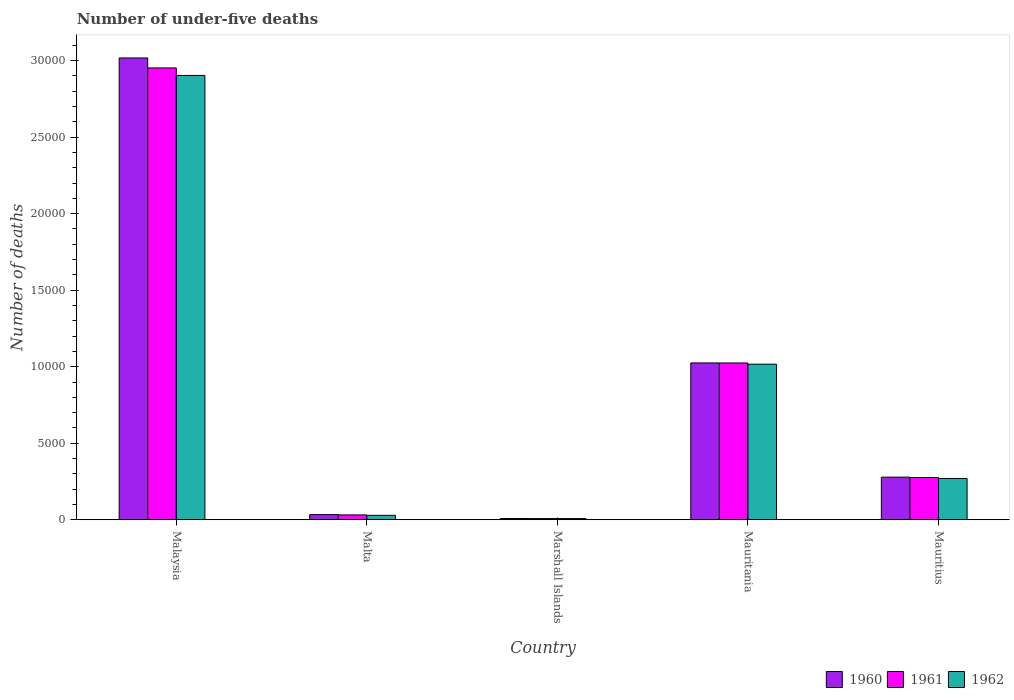How many different coloured bars are there?
Offer a very short reply. 3. Are the number of bars per tick equal to the number of legend labels?
Keep it short and to the point. Yes. Are the number of bars on each tick of the X-axis equal?
Provide a succinct answer. Yes. How many bars are there on the 5th tick from the left?
Your answer should be compact. 3. How many bars are there on the 4th tick from the right?
Make the answer very short. 3. What is the label of the 5th group of bars from the left?
Give a very brief answer. Mauritius. In how many cases, is the number of bars for a given country not equal to the number of legend labels?
Your response must be concise. 0. What is the number of under-five deaths in 1961 in Marshall Islands?
Make the answer very short. 79. Across all countries, what is the maximum number of under-five deaths in 1960?
Give a very brief answer. 3.02e+04. Across all countries, what is the minimum number of under-five deaths in 1962?
Give a very brief answer. 78. In which country was the number of under-five deaths in 1961 maximum?
Offer a very short reply. Malaysia. In which country was the number of under-five deaths in 1961 minimum?
Give a very brief answer. Marshall Islands. What is the total number of under-five deaths in 1962 in the graph?
Ensure brevity in your answer.  4.23e+04. What is the difference between the number of under-five deaths in 1962 in Malta and that in Mauritania?
Ensure brevity in your answer.  -9876. What is the difference between the number of under-five deaths in 1961 in Mauritius and the number of under-five deaths in 1962 in Mauritania?
Make the answer very short. -7404. What is the average number of under-five deaths in 1961 per country?
Offer a terse response. 8585.4. In how many countries, is the number of under-five deaths in 1961 greater than 20000?
Keep it short and to the point. 1. What is the ratio of the number of under-five deaths in 1960 in Mauritania to that in Mauritius?
Your response must be concise. 3.68. What is the difference between the highest and the second highest number of under-five deaths in 1960?
Offer a very short reply. 7463. What is the difference between the highest and the lowest number of under-five deaths in 1962?
Provide a short and direct response. 2.90e+04. Is the sum of the number of under-five deaths in 1960 in Marshall Islands and Mauritius greater than the maximum number of under-five deaths in 1961 across all countries?
Your response must be concise. No. What does the 1st bar from the left in Mauritania represents?
Your answer should be very brief. 1960. How many bars are there?
Make the answer very short. 15. How many countries are there in the graph?
Provide a succinct answer. 5. What is the difference between two consecutive major ticks on the Y-axis?
Give a very brief answer. 5000. Are the values on the major ticks of Y-axis written in scientific E-notation?
Give a very brief answer. No. Where does the legend appear in the graph?
Give a very brief answer. Bottom right. What is the title of the graph?
Provide a succinct answer. Number of under-five deaths. Does "1966" appear as one of the legend labels in the graph?
Offer a very short reply. No. What is the label or title of the Y-axis?
Provide a succinct answer. Number of deaths. What is the Number of deaths of 1960 in Malaysia?
Your response must be concise. 3.02e+04. What is the Number of deaths in 1961 in Malaysia?
Offer a very short reply. 2.95e+04. What is the Number of deaths in 1962 in Malaysia?
Ensure brevity in your answer.  2.90e+04. What is the Number of deaths in 1960 in Malta?
Give a very brief answer. 336. What is the Number of deaths of 1961 in Malta?
Your answer should be compact. 317. What is the Number of deaths of 1962 in Malta?
Your answer should be compact. 290. What is the Number of deaths of 1960 in Marshall Islands?
Provide a short and direct response. 81. What is the Number of deaths of 1961 in Marshall Islands?
Your answer should be compact. 79. What is the Number of deaths of 1962 in Marshall Islands?
Your response must be concise. 78. What is the Number of deaths in 1960 in Mauritania?
Provide a succinct answer. 1.02e+04. What is the Number of deaths of 1961 in Mauritania?
Your answer should be compact. 1.02e+04. What is the Number of deaths in 1962 in Mauritania?
Offer a terse response. 1.02e+04. What is the Number of deaths of 1960 in Mauritius?
Your answer should be compact. 2785. What is the Number of deaths of 1961 in Mauritius?
Your answer should be compact. 2762. What is the Number of deaths of 1962 in Mauritius?
Make the answer very short. 2697. Across all countries, what is the maximum Number of deaths of 1960?
Give a very brief answer. 3.02e+04. Across all countries, what is the maximum Number of deaths in 1961?
Give a very brief answer. 2.95e+04. Across all countries, what is the maximum Number of deaths of 1962?
Your answer should be compact. 2.90e+04. Across all countries, what is the minimum Number of deaths of 1960?
Offer a very short reply. 81. Across all countries, what is the minimum Number of deaths in 1961?
Your answer should be compact. 79. Across all countries, what is the minimum Number of deaths in 1962?
Your response must be concise. 78. What is the total Number of deaths in 1960 in the graph?
Offer a very short reply. 4.36e+04. What is the total Number of deaths in 1961 in the graph?
Ensure brevity in your answer.  4.29e+04. What is the total Number of deaths in 1962 in the graph?
Ensure brevity in your answer.  4.23e+04. What is the difference between the Number of deaths of 1960 in Malaysia and that in Malta?
Offer a terse response. 2.98e+04. What is the difference between the Number of deaths in 1961 in Malaysia and that in Malta?
Give a very brief answer. 2.92e+04. What is the difference between the Number of deaths in 1962 in Malaysia and that in Malta?
Give a very brief answer. 2.87e+04. What is the difference between the Number of deaths of 1960 in Malaysia and that in Marshall Islands?
Give a very brief answer. 3.01e+04. What is the difference between the Number of deaths of 1961 in Malaysia and that in Marshall Islands?
Give a very brief answer. 2.94e+04. What is the difference between the Number of deaths of 1962 in Malaysia and that in Marshall Islands?
Your response must be concise. 2.90e+04. What is the difference between the Number of deaths in 1960 in Malaysia and that in Mauritania?
Provide a succinct answer. 1.99e+04. What is the difference between the Number of deaths in 1961 in Malaysia and that in Mauritania?
Ensure brevity in your answer.  1.93e+04. What is the difference between the Number of deaths in 1962 in Malaysia and that in Mauritania?
Ensure brevity in your answer.  1.89e+04. What is the difference between the Number of deaths of 1960 in Malaysia and that in Mauritius?
Make the answer very short. 2.74e+04. What is the difference between the Number of deaths in 1961 in Malaysia and that in Mauritius?
Offer a very short reply. 2.68e+04. What is the difference between the Number of deaths in 1962 in Malaysia and that in Mauritius?
Offer a terse response. 2.63e+04. What is the difference between the Number of deaths of 1960 in Malta and that in Marshall Islands?
Give a very brief answer. 255. What is the difference between the Number of deaths in 1961 in Malta and that in Marshall Islands?
Ensure brevity in your answer.  238. What is the difference between the Number of deaths of 1962 in Malta and that in Marshall Islands?
Offer a terse response. 212. What is the difference between the Number of deaths in 1960 in Malta and that in Mauritania?
Offer a very short reply. -9912. What is the difference between the Number of deaths of 1961 in Malta and that in Mauritania?
Provide a short and direct response. -9928. What is the difference between the Number of deaths in 1962 in Malta and that in Mauritania?
Your answer should be very brief. -9876. What is the difference between the Number of deaths of 1960 in Malta and that in Mauritius?
Your answer should be very brief. -2449. What is the difference between the Number of deaths of 1961 in Malta and that in Mauritius?
Your answer should be very brief. -2445. What is the difference between the Number of deaths in 1962 in Malta and that in Mauritius?
Offer a terse response. -2407. What is the difference between the Number of deaths of 1960 in Marshall Islands and that in Mauritania?
Your answer should be very brief. -1.02e+04. What is the difference between the Number of deaths of 1961 in Marshall Islands and that in Mauritania?
Your answer should be compact. -1.02e+04. What is the difference between the Number of deaths of 1962 in Marshall Islands and that in Mauritania?
Make the answer very short. -1.01e+04. What is the difference between the Number of deaths of 1960 in Marshall Islands and that in Mauritius?
Your answer should be very brief. -2704. What is the difference between the Number of deaths in 1961 in Marshall Islands and that in Mauritius?
Provide a succinct answer. -2683. What is the difference between the Number of deaths in 1962 in Marshall Islands and that in Mauritius?
Give a very brief answer. -2619. What is the difference between the Number of deaths of 1960 in Mauritania and that in Mauritius?
Offer a terse response. 7463. What is the difference between the Number of deaths of 1961 in Mauritania and that in Mauritius?
Your answer should be compact. 7483. What is the difference between the Number of deaths in 1962 in Mauritania and that in Mauritius?
Offer a very short reply. 7469. What is the difference between the Number of deaths of 1960 in Malaysia and the Number of deaths of 1961 in Malta?
Give a very brief answer. 2.99e+04. What is the difference between the Number of deaths in 1960 in Malaysia and the Number of deaths in 1962 in Malta?
Keep it short and to the point. 2.99e+04. What is the difference between the Number of deaths of 1961 in Malaysia and the Number of deaths of 1962 in Malta?
Ensure brevity in your answer.  2.92e+04. What is the difference between the Number of deaths in 1960 in Malaysia and the Number of deaths in 1961 in Marshall Islands?
Offer a very short reply. 3.01e+04. What is the difference between the Number of deaths in 1960 in Malaysia and the Number of deaths in 1962 in Marshall Islands?
Your answer should be very brief. 3.01e+04. What is the difference between the Number of deaths of 1961 in Malaysia and the Number of deaths of 1962 in Marshall Islands?
Your answer should be very brief. 2.94e+04. What is the difference between the Number of deaths in 1960 in Malaysia and the Number of deaths in 1961 in Mauritania?
Provide a succinct answer. 1.99e+04. What is the difference between the Number of deaths of 1960 in Malaysia and the Number of deaths of 1962 in Mauritania?
Offer a terse response. 2.00e+04. What is the difference between the Number of deaths in 1961 in Malaysia and the Number of deaths in 1962 in Mauritania?
Offer a terse response. 1.94e+04. What is the difference between the Number of deaths in 1960 in Malaysia and the Number of deaths in 1961 in Mauritius?
Offer a terse response. 2.74e+04. What is the difference between the Number of deaths in 1960 in Malaysia and the Number of deaths in 1962 in Mauritius?
Ensure brevity in your answer.  2.75e+04. What is the difference between the Number of deaths of 1961 in Malaysia and the Number of deaths of 1962 in Mauritius?
Provide a short and direct response. 2.68e+04. What is the difference between the Number of deaths in 1960 in Malta and the Number of deaths in 1961 in Marshall Islands?
Offer a very short reply. 257. What is the difference between the Number of deaths in 1960 in Malta and the Number of deaths in 1962 in Marshall Islands?
Keep it short and to the point. 258. What is the difference between the Number of deaths in 1961 in Malta and the Number of deaths in 1962 in Marshall Islands?
Make the answer very short. 239. What is the difference between the Number of deaths of 1960 in Malta and the Number of deaths of 1961 in Mauritania?
Your response must be concise. -9909. What is the difference between the Number of deaths in 1960 in Malta and the Number of deaths in 1962 in Mauritania?
Your response must be concise. -9830. What is the difference between the Number of deaths of 1961 in Malta and the Number of deaths of 1962 in Mauritania?
Offer a terse response. -9849. What is the difference between the Number of deaths of 1960 in Malta and the Number of deaths of 1961 in Mauritius?
Provide a short and direct response. -2426. What is the difference between the Number of deaths of 1960 in Malta and the Number of deaths of 1962 in Mauritius?
Give a very brief answer. -2361. What is the difference between the Number of deaths of 1961 in Malta and the Number of deaths of 1962 in Mauritius?
Provide a short and direct response. -2380. What is the difference between the Number of deaths of 1960 in Marshall Islands and the Number of deaths of 1961 in Mauritania?
Give a very brief answer. -1.02e+04. What is the difference between the Number of deaths of 1960 in Marshall Islands and the Number of deaths of 1962 in Mauritania?
Make the answer very short. -1.01e+04. What is the difference between the Number of deaths of 1961 in Marshall Islands and the Number of deaths of 1962 in Mauritania?
Give a very brief answer. -1.01e+04. What is the difference between the Number of deaths of 1960 in Marshall Islands and the Number of deaths of 1961 in Mauritius?
Offer a terse response. -2681. What is the difference between the Number of deaths in 1960 in Marshall Islands and the Number of deaths in 1962 in Mauritius?
Keep it short and to the point. -2616. What is the difference between the Number of deaths of 1961 in Marshall Islands and the Number of deaths of 1962 in Mauritius?
Your answer should be very brief. -2618. What is the difference between the Number of deaths in 1960 in Mauritania and the Number of deaths in 1961 in Mauritius?
Provide a short and direct response. 7486. What is the difference between the Number of deaths of 1960 in Mauritania and the Number of deaths of 1962 in Mauritius?
Your response must be concise. 7551. What is the difference between the Number of deaths of 1961 in Mauritania and the Number of deaths of 1962 in Mauritius?
Provide a succinct answer. 7548. What is the average Number of deaths of 1960 per country?
Your answer should be very brief. 8725. What is the average Number of deaths in 1961 per country?
Provide a succinct answer. 8585.4. What is the average Number of deaths in 1962 per country?
Give a very brief answer. 8452.8. What is the difference between the Number of deaths of 1960 and Number of deaths of 1961 in Malaysia?
Offer a very short reply. 651. What is the difference between the Number of deaths in 1960 and Number of deaths in 1962 in Malaysia?
Offer a terse response. 1142. What is the difference between the Number of deaths in 1961 and Number of deaths in 1962 in Malaysia?
Offer a very short reply. 491. What is the difference between the Number of deaths in 1960 and Number of deaths in 1962 in Malta?
Offer a very short reply. 46. What is the difference between the Number of deaths in 1961 and Number of deaths in 1962 in Marshall Islands?
Your answer should be compact. 1. What is the difference between the Number of deaths in 1960 and Number of deaths in 1962 in Mauritania?
Offer a terse response. 82. What is the difference between the Number of deaths in 1961 and Number of deaths in 1962 in Mauritania?
Keep it short and to the point. 79. What is the difference between the Number of deaths of 1960 and Number of deaths of 1962 in Mauritius?
Your answer should be compact. 88. What is the ratio of the Number of deaths in 1960 in Malaysia to that in Malta?
Your answer should be compact. 89.81. What is the ratio of the Number of deaths in 1961 in Malaysia to that in Malta?
Offer a terse response. 93.14. What is the ratio of the Number of deaths of 1962 in Malaysia to that in Malta?
Give a very brief answer. 100.11. What is the ratio of the Number of deaths of 1960 in Malaysia to that in Marshall Islands?
Offer a very short reply. 372.53. What is the ratio of the Number of deaths in 1961 in Malaysia to that in Marshall Islands?
Offer a very short reply. 373.72. What is the ratio of the Number of deaths of 1962 in Malaysia to that in Marshall Islands?
Offer a very short reply. 372.22. What is the ratio of the Number of deaths in 1960 in Malaysia to that in Mauritania?
Make the answer very short. 2.94. What is the ratio of the Number of deaths in 1961 in Malaysia to that in Mauritania?
Your answer should be compact. 2.88. What is the ratio of the Number of deaths in 1962 in Malaysia to that in Mauritania?
Keep it short and to the point. 2.86. What is the ratio of the Number of deaths in 1960 in Malaysia to that in Mauritius?
Provide a succinct answer. 10.83. What is the ratio of the Number of deaths of 1961 in Malaysia to that in Mauritius?
Keep it short and to the point. 10.69. What is the ratio of the Number of deaths in 1962 in Malaysia to that in Mauritius?
Provide a succinct answer. 10.76. What is the ratio of the Number of deaths of 1960 in Malta to that in Marshall Islands?
Your answer should be very brief. 4.15. What is the ratio of the Number of deaths in 1961 in Malta to that in Marshall Islands?
Provide a short and direct response. 4.01. What is the ratio of the Number of deaths of 1962 in Malta to that in Marshall Islands?
Make the answer very short. 3.72. What is the ratio of the Number of deaths in 1960 in Malta to that in Mauritania?
Provide a short and direct response. 0.03. What is the ratio of the Number of deaths of 1961 in Malta to that in Mauritania?
Ensure brevity in your answer.  0.03. What is the ratio of the Number of deaths in 1962 in Malta to that in Mauritania?
Give a very brief answer. 0.03. What is the ratio of the Number of deaths of 1960 in Malta to that in Mauritius?
Your answer should be compact. 0.12. What is the ratio of the Number of deaths in 1961 in Malta to that in Mauritius?
Your answer should be very brief. 0.11. What is the ratio of the Number of deaths in 1962 in Malta to that in Mauritius?
Give a very brief answer. 0.11. What is the ratio of the Number of deaths in 1960 in Marshall Islands to that in Mauritania?
Your answer should be very brief. 0.01. What is the ratio of the Number of deaths of 1961 in Marshall Islands to that in Mauritania?
Keep it short and to the point. 0.01. What is the ratio of the Number of deaths of 1962 in Marshall Islands to that in Mauritania?
Provide a short and direct response. 0.01. What is the ratio of the Number of deaths in 1960 in Marshall Islands to that in Mauritius?
Your answer should be very brief. 0.03. What is the ratio of the Number of deaths of 1961 in Marshall Islands to that in Mauritius?
Provide a succinct answer. 0.03. What is the ratio of the Number of deaths in 1962 in Marshall Islands to that in Mauritius?
Your response must be concise. 0.03. What is the ratio of the Number of deaths in 1960 in Mauritania to that in Mauritius?
Keep it short and to the point. 3.68. What is the ratio of the Number of deaths in 1961 in Mauritania to that in Mauritius?
Your response must be concise. 3.71. What is the ratio of the Number of deaths of 1962 in Mauritania to that in Mauritius?
Offer a very short reply. 3.77. What is the difference between the highest and the second highest Number of deaths of 1960?
Offer a terse response. 1.99e+04. What is the difference between the highest and the second highest Number of deaths of 1961?
Provide a succinct answer. 1.93e+04. What is the difference between the highest and the second highest Number of deaths in 1962?
Ensure brevity in your answer.  1.89e+04. What is the difference between the highest and the lowest Number of deaths of 1960?
Ensure brevity in your answer.  3.01e+04. What is the difference between the highest and the lowest Number of deaths in 1961?
Make the answer very short. 2.94e+04. What is the difference between the highest and the lowest Number of deaths of 1962?
Give a very brief answer. 2.90e+04. 